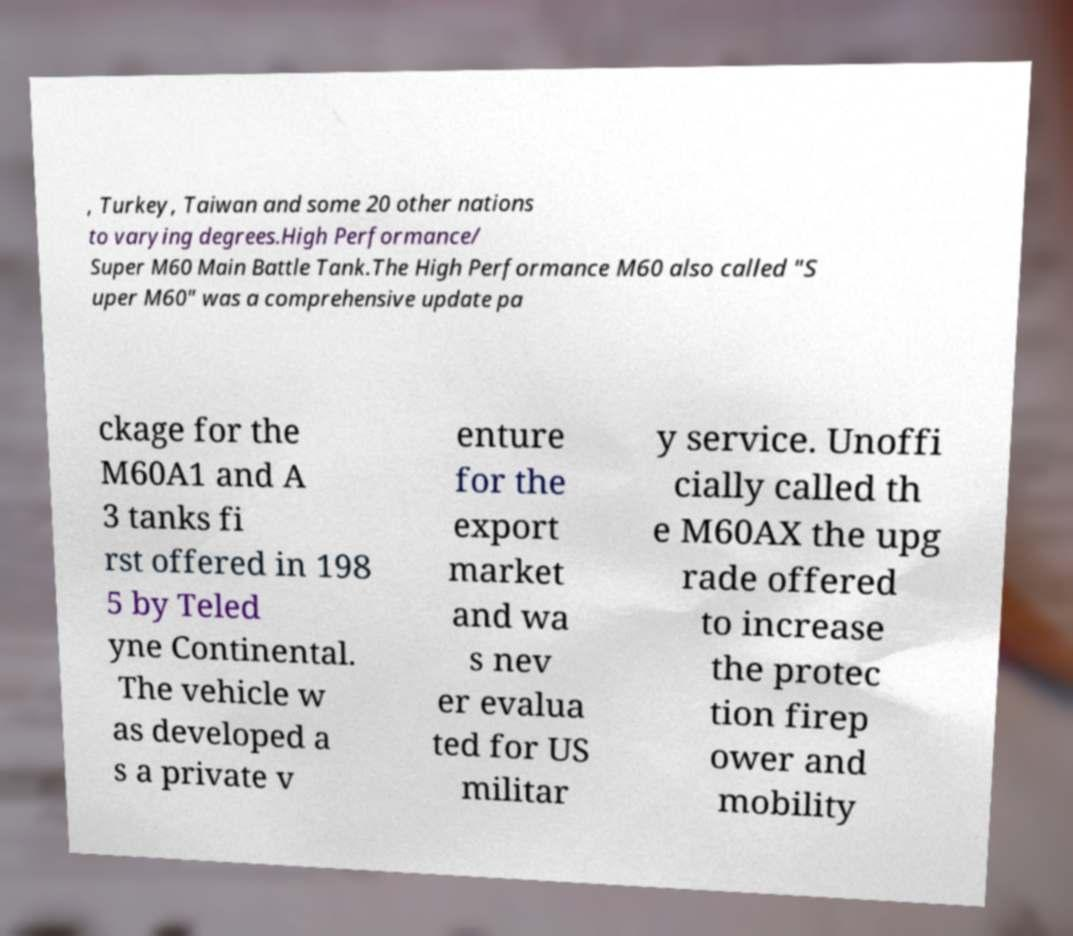Please identify and transcribe the text found in this image. , Turkey, Taiwan and some 20 other nations to varying degrees.High Performance/ Super M60 Main Battle Tank.The High Performance M60 also called "S uper M60" was a comprehensive update pa ckage for the M60A1 and A 3 tanks fi rst offered in 198 5 by Teled yne Continental. The vehicle w as developed a s a private v enture for the export market and wa s nev er evalua ted for US militar y service. Unoffi cially called th e M60AX the upg rade offered to increase the protec tion firep ower and mobility 